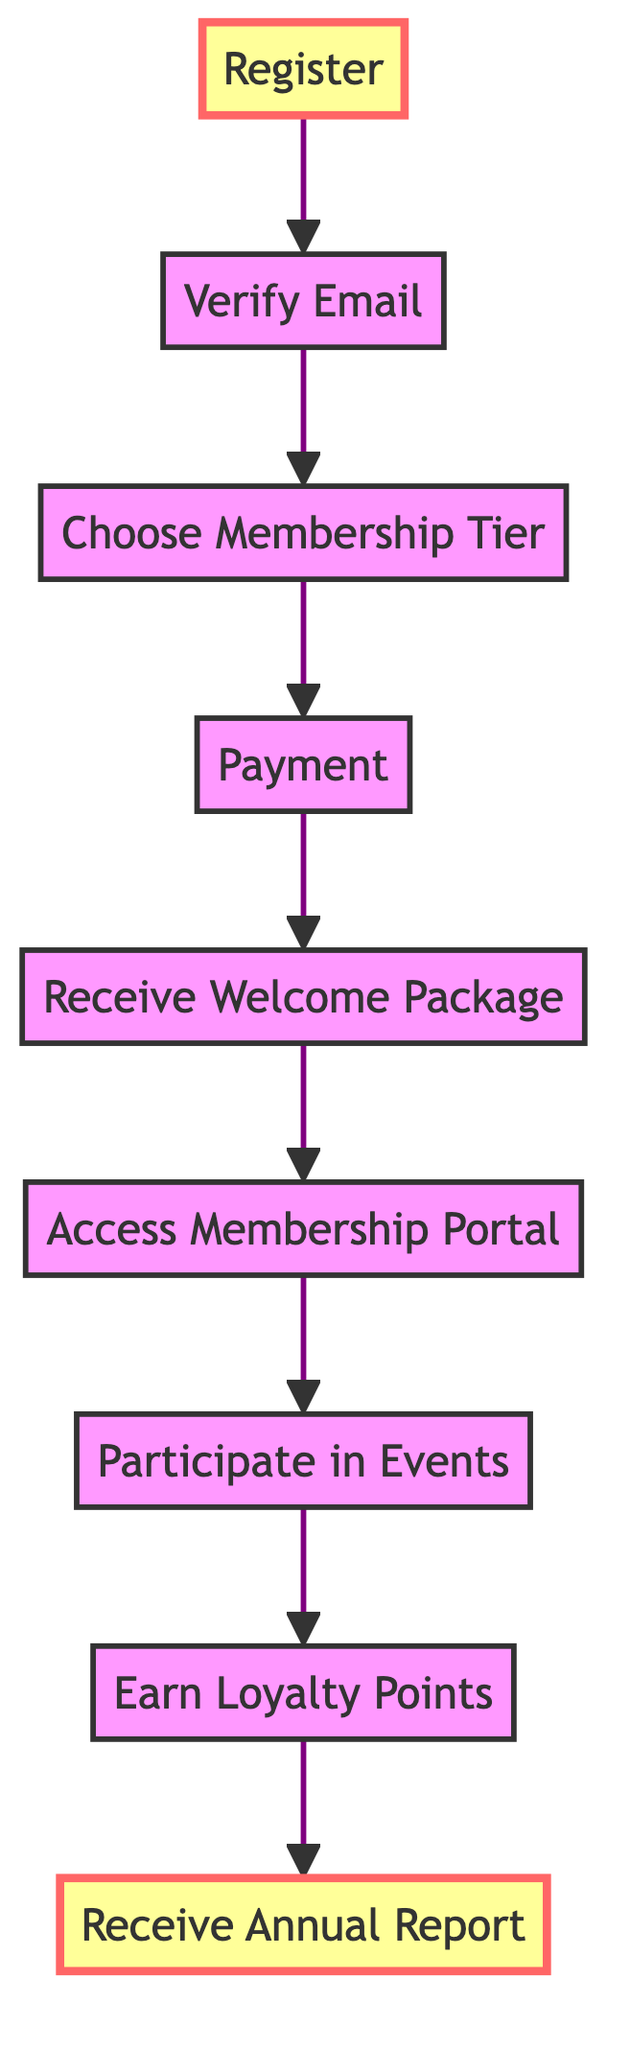What is the final step in the process? The final step in the process is indicated by the last node in the flowchart, which is labeled "Receive Annual Report." This shows the last action a supporter takes after completing all previous steps.
Answer: Receive Annual Report How many steps are in the flowchart? All nodes in the flowchart represent distinct steps in the process. By counting the nodes labeled from step 1 to step 9, we find there are nine steps total.
Answer: 9 What comes after "Access Membership Portal"? By following the flow from the node labeled "Access Membership Portal," the next step is indicated as "Participate in Events," which is the subsequent action a supporter takes.
Answer: Participate in Events What must be done before selecting a membership tier? The flowchart shows that the step immediately prior to "Choose Membership Tier" is "Verify Email," indicating this must be completed before making the selection of a membership tier.
Answer: Verify Email What is the first action to become a supporter? The first action indicated by the flowchart is labeled "Register," which means signing up on the official Hubert Berchtold Supporters Club website is the first step.
Answer: Register How can supporters earn rewards? By looking at the flowchart, we see that supporters earn rewards by completing the step labeled "Earn Loyalty Points," which is a result of participating in activities and renewing membership.
Answer: Earn Loyalty Points What is included in the welcome package? The welcome package is described in the step labeled "Receive Welcome Package," where it specifies that it includes a personalized supporter card, exclusive merchandise, and a thank-you letter from Hubert Berchtold.
Answer: Personalized supporter card, exclusive merchandise, and thank-you letter What action occurs directly after payment? Following the payment step in the flow is the step labeled "Receive Welcome Package," which delineates the immediate action that occurs after successfully completing payment.
Answer: Receive Welcome Package What type of events can members participate in? According to the flowchart, members can participate in both virtual and physical events as indicated in the "Participate in Events" step. This encompasses live Q&A sessions, fan meet-ups, and annual conventions.
Answer: Virtual and physical events 